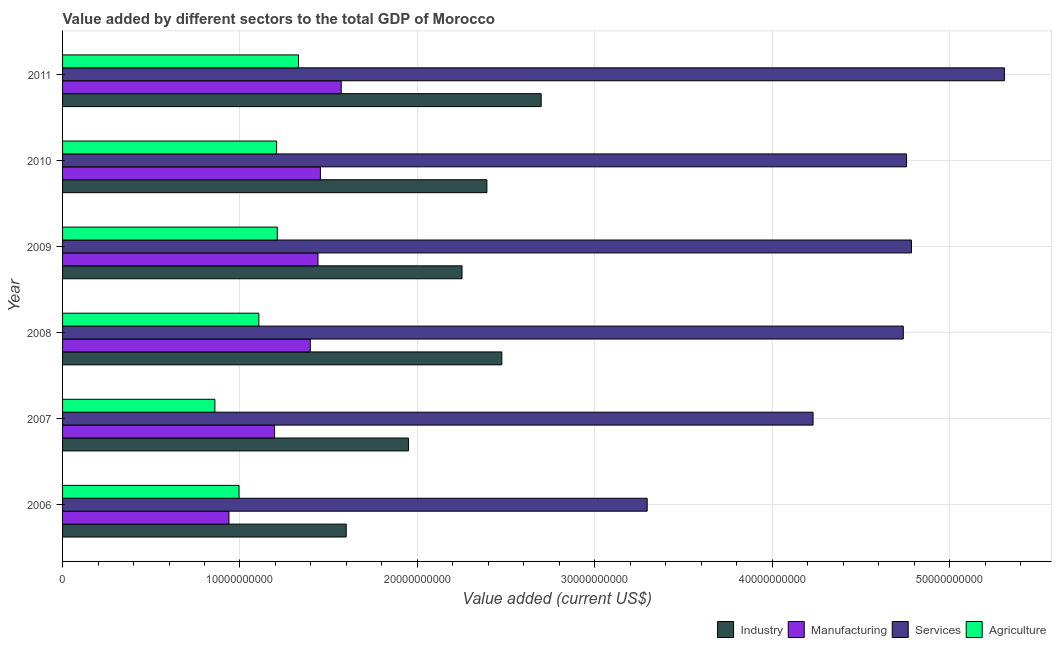Are the number of bars per tick equal to the number of legend labels?
Provide a short and direct response. Yes. Are the number of bars on each tick of the Y-axis equal?
Your answer should be compact. Yes. What is the label of the 1st group of bars from the top?
Your answer should be very brief. 2011. What is the value added by services sector in 2008?
Your answer should be very brief. 4.74e+1. Across all years, what is the maximum value added by manufacturing sector?
Your answer should be very brief. 1.57e+1. Across all years, what is the minimum value added by services sector?
Give a very brief answer. 3.30e+1. What is the total value added by agricultural sector in the graph?
Your answer should be compact. 6.71e+1. What is the difference between the value added by industrial sector in 2009 and that in 2011?
Your response must be concise. -4.46e+09. What is the difference between the value added by services sector in 2006 and the value added by industrial sector in 2008?
Make the answer very short. 8.19e+09. What is the average value added by agricultural sector per year?
Keep it short and to the point. 1.12e+1. In the year 2009, what is the difference between the value added by industrial sector and value added by agricultural sector?
Ensure brevity in your answer.  1.04e+1. In how many years, is the value added by agricultural sector greater than 22000000000 US$?
Your answer should be compact. 0. Is the difference between the value added by manufacturing sector in 2008 and 2009 greater than the difference between the value added by agricultural sector in 2008 and 2009?
Your answer should be very brief. Yes. What is the difference between the highest and the second highest value added by services sector?
Provide a short and direct response. 5.24e+09. What is the difference between the highest and the lowest value added by manufacturing sector?
Offer a terse response. 6.33e+09. Is the sum of the value added by services sector in 2007 and 2011 greater than the maximum value added by industrial sector across all years?
Provide a succinct answer. Yes. Is it the case that in every year, the sum of the value added by industrial sector and value added by services sector is greater than the sum of value added by manufacturing sector and value added by agricultural sector?
Provide a succinct answer. Yes. What does the 1st bar from the top in 2007 represents?
Keep it short and to the point. Agriculture. What does the 3rd bar from the bottom in 2006 represents?
Keep it short and to the point. Services. Is it the case that in every year, the sum of the value added by industrial sector and value added by manufacturing sector is greater than the value added by services sector?
Make the answer very short. No. What is the difference between two consecutive major ticks on the X-axis?
Offer a terse response. 1.00e+1. Does the graph contain any zero values?
Provide a short and direct response. No. Where does the legend appear in the graph?
Offer a terse response. Bottom right. How are the legend labels stacked?
Provide a succinct answer. Horizontal. What is the title of the graph?
Provide a short and direct response. Value added by different sectors to the total GDP of Morocco. What is the label or title of the X-axis?
Make the answer very short. Value added (current US$). What is the label or title of the Y-axis?
Offer a terse response. Year. What is the Value added (current US$) in Industry in 2006?
Make the answer very short. 1.60e+1. What is the Value added (current US$) in Manufacturing in 2006?
Ensure brevity in your answer.  9.38e+09. What is the Value added (current US$) in Services in 2006?
Provide a short and direct response. 3.30e+1. What is the Value added (current US$) of Agriculture in 2006?
Offer a terse response. 9.95e+09. What is the Value added (current US$) of Industry in 2007?
Your answer should be compact. 1.95e+1. What is the Value added (current US$) of Manufacturing in 2007?
Your answer should be very brief. 1.20e+1. What is the Value added (current US$) of Services in 2007?
Your response must be concise. 4.23e+1. What is the Value added (current US$) in Agriculture in 2007?
Make the answer very short. 8.59e+09. What is the Value added (current US$) in Industry in 2008?
Give a very brief answer. 2.48e+1. What is the Value added (current US$) of Manufacturing in 2008?
Provide a succinct answer. 1.40e+1. What is the Value added (current US$) in Services in 2008?
Provide a short and direct response. 4.74e+1. What is the Value added (current US$) of Agriculture in 2008?
Offer a very short reply. 1.11e+1. What is the Value added (current US$) in Industry in 2009?
Give a very brief answer. 2.25e+1. What is the Value added (current US$) in Manufacturing in 2009?
Ensure brevity in your answer.  1.44e+1. What is the Value added (current US$) of Services in 2009?
Provide a short and direct response. 4.78e+1. What is the Value added (current US$) in Agriculture in 2009?
Make the answer very short. 1.21e+1. What is the Value added (current US$) in Industry in 2010?
Offer a terse response. 2.39e+1. What is the Value added (current US$) of Manufacturing in 2010?
Make the answer very short. 1.45e+1. What is the Value added (current US$) in Services in 2010?
Your response must be concise. 4.76e+1. What is the Value added (current US$) in Agriculture in 2010?
Your answer should be very brief. 1.21e+1. What is the Value added (current US$) of Industry in 2011?
Your answer should be very brief. 2.70e+1. What is the Value added (current US$) in Manufacturing in 2011?
Provide a short and direct response. 1.57e+1. What is the Value added (current US$) in Services in 2011?
Offer a terse response. 5.31e+1. What is the Value added (current US$) of Agriculture in 2011?
Keep it short and to the point. 1.33e+1. Across all years, what is the maximum Value added (current US$) in Industry?
Offer a very short reply. 2.70e+1. Across all years, what is the maximum Value added (current US$) of Manufacturing?
Ensure brevity in your answer.  1.57e+1. Across all years, what is the maximum Value added (current US$) in Services?
Make the answer very short. 5.31e+1. Across all years, what is the maximum Value added (current US$) in Agriculture?
Ensure brevity in your answer.  1.33e+1. Across all years, what is the minimum Value added (current US$) in Industry?
Provide a succinct answer. 1.60e+1. Across all years, what is the minimum Value added (current US$) in Manufacturing?
Keep it short and to the point. 9.38e+09. Across all years, what is the minimum Value added (current US$) in Services?
Give a very brief answer. 3.30e+1. Across all years, what is the minimum Value added (current US$) of Agriculture?
Give a very brief answer. 8.59e+09. What is the total Value added (current US$) of Industry in the graph?
Make the answer very short. 1.34e+11. What is the total Value added (current US$) in Manufacturing in the graph?
Your response must be concise. 7.99e+1. What is the total Value added (current US$) in Services in the graph?
Make the answer very short. 2.71e+11. What is the total Value added (current US$) in Agriculture in the graph?
Ensure brevity in your answer.  6.71e+1. What is the difference between the Value added (current US$) of Industry in 2006 and that in 2007?
Your answer should be compact. -3.51e+09. What is the difference between the Value added (current US$) of Manufacturing in 2006 and that in 2007?
Provide a short and direct response. -2.57e+09. What is the difference between the Value added (current US$) of Services in 2006 and that in 2007?
Provide a short and direct response. -9.35e+09. What is the difference between the Value added (current US$) of Agriculture in 2006 and that in 2007?
Your response must be concise. 1.36e+09. What is the difference between the Value added (current US$) of Industry in 2006 and that in 2008?
Provide a succinct answer. -8.77e+09. What is the difference between the Value added (current US$) in Manufacturing in 2006 and that in 2008?
Give a very brief answer. -4.58e+09. What is the difference between the Value added (current US$) of Services in 2006 and that in 2008?
Provide a short and direct response. -1.44e+1. What is the difference between the Value added (current US$) of Agriculture in 2006 and that in 2008?
Ensure brevity in your answer.  -1.12e+09. What is the difference between the Value added (current US$) of Industry in 2006 and that in 2009?
Offer a very short reply. -6.53e+09. What is the difference between the Value added (current US$) of Manufacturing in 2006 and that in 2009?
Provide a succinct answer. -5.02e+09. What is the difference between the Value added (current US$) of Services in 2006 and that in 2009?
Provide a short and direct response. -1.49e+1. What is the difference between the Value added (current US$) in Agriculture in 2006 and that in 2009?
Your response must be concise. -2.16e+09. What is the difference between the Value added (current US$) in Industry in 2006 and that in 2010?
Give a very brief answer. -7.93e+09. What is the difference between the Value added (current US$) of Manufacturing in 2006 and that in 2010?
Keep it short and to the point. -5.15e+09. What is the difference between the Value added (current US$) in Services in 2006 and that in 2010?
Ensure brevity in your answer.  -1.46e+1. What is the difference between the Value added (current US$) in Agriculture in 2006 and that in 2010?
Offer a very short reply. -2.12e+09. What is the difference between the Value added (current US$) of Industry in 2006 and that in 2011?
Your answer should be compact. -1.10e+1. What is the difference between the Value added (current US$) in Manufacturing in 2006 and that in 2011?
Your response must be concise. -6.33e+09. What is the difference between the Value added (current US$) in Services in 2006 and that in 2011?
Make the answer very short. -2.01e+1. What is the difference between the Value added (current US$) of Agriculture in 2006 and that in 2011?
Offer a terse response. -3.35e+09. What is the difference between the Value added (current US$) of Industry in 2007 and that in 2008?
Your answer should be compact. -5.26e+09. What is the difference between the Value added (current US$) in Manufacturing in 2007 and that in 2008?
Offer a very short reply. -2.01e+09. What is the difference between the Value added (current US$) in Services in 2007 and that in 2008?
Offer a terse response. -5.09e+09. What is the difference between the Value added (current US$) in Agriculture in 2007 and that in 2008?
Ensure brevity in your answer.  -2.48e+09. What is the difference between the Value added (current US$) in Industry in 2007 and that in 2009?
Provide a succinct answer. -3.02e+09. What is the difference between the Value added (current US$) of Manufacturing in 2007 and that in 2009?
Provide a succinct answer. -2.45e+09. What is the difference between the Value added (current US$) of Services in 2007 and that in 2009?
Provide a succinct answer. -5.55e+09. What is the difference between the Value added (current US$) of Agriculture in 2007 and that in 2009?
Keep it short and to the point. -3.52e+09. What is the difference between the Value added (current US$) of Industry in 2007 and that in 2010?
Your answer should be very brief. -4.42e+09. What is the difference between the Value added (current US$) of Manufacturing in 2007 and that in 2010?
Keep it short and to the point. -2.58e+09. What is the difference between the Value added (current US$) of Services in 2007 and that in 2010?
Ensure brevity in your answer.  -5.27e+09. What is the difference between the Value added (current US$) of Agriculture in 2007 and that in 2010?
Keep it short and to the point. -3.48e+09. What is the difference between the Value added (current US$) in Industry in 2007 and that in 2011?
Your answer should be compact. -7.48e+09. What is the difference between the Value added (current US$) in Manufacturing in 2007 and that in 2011?
Make the answer very short. -3.76e+09. What is the difference between the Value added (current US$) in Services in 2007 and that in 2011?
Ensure brevity in your answer.  -1.08e+1. What is the difference between the Value added (current US$) in Agriculture in 2007 and that in 2011?
Offer a terse response. -4.71e+09. What is the difference between the Value added (current US$) of Industry in 2008 and that in 2009?
Ensure brevity in your answer.  2.24e+09. What is the difference between the Value added (current US$) in Manufacturing in 2008 and that in 2009?
Your response must be concise. -4.36e+08. What is the difference between the Value added (current US$) of Services in 2008 and that in 2009?
Make the answer very short. -4.59e+08. What is the difference between the Value added (current US$) of Agriculture in 2008 and that in 2009?
Offer a very short reply. -1.04e+09. What is the difference between the Value added (current US$) in Industry in 2008 and that in 2010?
Provide a short and direct response. 8.42e+08. What is the difference between the Value added (current US$) of Manufacturing in 2008 and that in 2010?
Provide a short and direct response. -5.71e+08. What is the difference between the Value added (current US$) in Services in 2008 and that in 2010?
Offer a terse response. -1.85e+08. What is the difference between the Value added (current US$) in Agriculture in 2008 and that in 2010?
Give a very brief answer. -1.00e+09. What is the difference between the Value added (current US$) of Industry in 2008 and that in 2011?
Your answer should be compact. -2.22e+09. What is the difference between the Value added (current US$) in Manufacturing in 2008 and that in 2011?
Offer a very short reply. -1.74e+09. What is the difference between the Value added (current US$) of Services in 2008 and that in 2011?
Your answer should be very brief. -5.70e+09. What is the difference between the Value added (current US$) in Agriculture in 2008 and that in 2011?
Keep it short and to the point. -2.24e+09. What is the difference between the Value added (current US$) in Industry in 2009 and that in 2010?
Your answer should be compact. -1.40e+09. What is the difference between the Value added (current US$) of Manufacturing in 2009 and that in 2010?
Give a very brief answer. -1.35e+08. What is the difference between the Value added (current US$) of Services in 2009 and that in 2010?
Keep it short and to the point. 2.74e+08. What is the difference between the Value added (current US$) of Agriculture in 2009 and that in 2010?
Your answer should be very brief. 3.77e+07. What is the difference between the Value added (current US$) in Industry in 2009 and that in 2011?
Offer a very short reply. -4.46e+09. What is the difference between the Value added (current US$) in Manufacturing in 2009 and that in 2011?
Your answer should be compact. -1.31e+09. What is the difference between the Value added (current US$) of Services in 2009 and that in 2011?
Keep it short and to the point. -5.24e+09. What is the difference between the Value added (current US$) of Agriculture in 2009 and that in 2011?
Your answer should be compact. -1.20e+09. What is the difference between the Value added (current US$) of Industry in 2010 and that in 2011?
Your answer should be compact. -3.06e+09. What is the difference between the Value added (current US$) of Manufacturing in 2010 and that in 2011?
Provide a succinct answer. -1.17e+09. What is the difference between the Value added (current US$) in Services in 2010 and that in 2011?
Offer a terse response. -5.51e+09. What is the difference between the Value added (current US$) of Agriculture in 2010 and that in 2011?
Make the answer very short. -1.23e+09. What is the difference between the Value added (current US$) of Industry in 2006 and the Value added (current US$) of Manufacturing in 2007?
Offer a terse response. 4.04e+09. What is the difference between the Value added (current US$) in Industry in 2006 and the Value added (current US$) in Services in 2007?
Offer a very short reply. -2.63e+1. What is the difference between the Value added (current US$) of Industry in 2006 and the Value added (current US$) of Agriculture in 2007?
Give a very brief answer. 7.40e+09. What is the difference between the Value added (current US$) in Manufacturing in 2006 and the Value added (current US$) in Services in 2007?
Offer a terse response. -3.29e+1. What is the difference between the Value added (current US$) of Manufacturing in 2006 and the Value added (current US$) of Agriculture in 2007?
Ensure brevity in your answer.  7.93e+08. What is the difference between the Value added (current US$) in Services in 2006 and the Value added (current US$) in Agriculture in 2007?
Provide a short and direct response. 2.44e+1. What is the difference between the Value added (current US$) of Industry in 2006 and the Value added (current US$) of Manufacturing in 2008?
Your answer should be very brief. 2.03e+09. What is the difference between the Value added (current US$) in Industry in 2006 and the Value added (current US$) in Services in 2008?
Make the answer very short. -3.14e+1. What is the difference between the Value added (current US$) of Industry in 2006 and the Value added (current US$) of Agriculture in 2008?
Offer a very short reply. 4.93e+09. What is the difference between the Value added (current US$) of Manufacturing in 2006 and the Value added (current US$) of Services in 2008?
Make the answer very short. -3.80e+1. What is the difference between the Value added (current US$) in Manufacturing in 2006 and the Value added (current US$) in Agriculture in 2008?
Make the answer very short. -1.68e+09. What is the difference between the Value added (current US$) in Services in 2006 and the Value added (current US$) in Agriculture in 2008?
Provide a succinct answer. 2.19e+1. What is the difference between the Value added (current US$) of Industry in 2006 and the Value added (current US$) of Manufacturing in 2009?
Provide a short and direct response. 1.59e+09. What is the difference between the Value added (current US$) in Industry in 2006 and the Value added (current US$) in Services in 2009?
Your answer should be compact. -3.19e+1. What is the difference between the Value added (current US$) in Industry in 2006 and the Value added (current US$) in Agriculture in 2009?
Give a very brief answer. 3.89e+09. What is the difference between the Value added (current US$) of Manufacturing in 2006 and the Value added (current US$) of Services in 2009?
Make the answer very short. -3.85e+1. What is the difference between the Value added (current US$) of Manufacturing in 2006 and the Value added (current US$) of Agriculture in 2009?
Ensure brevity in your answer.  -2.72e+09. What is the difference between the Value added (current US$) of Services in 2006 and the Value added (current US$) of Agriculture in 2009?
Your answer should be compact. 2.08e+1. What is the difference between the Value added (current US$) in Industry in 2006 and the Value added (current US$) in Manufacturing in 2010?
Provide a short and direct response. 1.46e+09. What is the difference between the Value added (current US$) in Industry in 2006 and the Value added (current US$) in Services in 2010?
Your answer should be compact. -3.16e+1. What is the difference between the Value added (current US$) in Industry in 2006 and the Value added (current US$) in Agriculture in 2010?
Make the answer very short. 3.92e+09. What is the difference between the Value added (current US$) of Manufacturing in 2006 and the Value added (current US$) of Services in 2010?
Make the answer very short. -3.82e+1. What is the difference between the Value added (current US$) of Manufacturing in 2006 and the Value added (current US$) of Agriculture in 2010?
Make the answer very short. -2.69e+09. What is the difference between the Value added (current US$) in Services in 2006 and the Value added (current US$) in Agriculture in 2010?
Your response must be concise. 2.09e+1. What is the difference between the Value added (current US$) of Industry in 2006 and the Value added (current US$) of Manufacturing in 2011?
Offer a very short reply. 2.83e+08. What is the difference between the Value added (current US$) of Industry in 2006 and the Value added (current US$) of Services in 2011?
Make the answer very short. -3.71e+1. What is the difference between the Value added (current US$) in Industry in 2006 and the Value added (current US$) in Agriculture in 2011?
Keep it short and to the point. 2.69e+09. What is the difference between the Value added (current US$) of Manufacturing in 2006 and the Value added (current US$) of Services in 2011?
Make the answer very short. -4.37e+1. What is the difference between the Value added (current US$) of Manufacturing in 2006 and the Value added (current US$) of Agriculture in 2011?
Keep it short and to the point. -3.92e+09. What is the difference between the Value added (current US$) of Services in 2006 and the Value added (current US$) of Agriculture in 2011?
Provide a short and direct response. 1.97e+1. What is the difference between the Value added (current US$) of Industry in 2007 and the Value added (current US$) of Manufacturing in 2008?
Offer a very short reply. 5.53e+09. What is the difference between the Value added (current US$) in Industry in 2007 and the Value added (current US$) in Services in 2008?
Your answer should be compact. -2.79e+1. What is the difference between the Value added (current US$) in Industry in 2007 and the Value added (current US$) in Agriculture in 2008?
Offer a very short reply. 8.43e+09. What is the difference between the Value added (current US$) in Manufacturing in 2007 and the Value added (current US$) in Services in 2008?
Keep it short and to the point. -3.54e+1. What is the difference between the Value added (current US$) in Manufacturing in 2007 and the Value added (current US$) in Agriculture in 2008?
Your answer should be compact. 8.87e+08. What is the difference between the Value added (current US$) of Services in 2007 and the Value added (current US$) of Agriculture in 2008?
Provide a short and direct response. 3.12e+1. What is the difference between the Value added (current US$) of Industry in 2007 and the Value added (current US$) of Manufacturing in 2009?
Your response must be concise. 5.10e+09. What is the difference between the Value added (current US$) of Industry in 2007 and the Value added (current US$) of Services in 2009?
Ensure brevity in your answer.  -2.84e+1. What is the difference between the Value added (current US$) of Industry in 2007 and the Value added (current US$) of Agriculture in 2009?
Your answer should be very brief. 7.39e+09. What is the difference between the Value added (current US$) in Manufacturing in 2007 and the Value added (current US$) in Services in 2009?
Ensure brevity in your answer.  -3.59e+1. What is the difference between the Value added (current US$) in Manufacturing in 2007 and the Value added (current US$) in Agriculture in 2009?
Provide a succinct answer. -1.53e+08. What is the difference between the Value added (current US$) of Services in 2007 and the Value added (current US$) of Agriculture in 2009?
Give a very brief answer. 3.02e+1. What is the difference between the Value added (current US$) in Industry in 2007 and the Value added (current US$) in Manufacturing in 2010?
Your answer should be compact. 4.96e+09. What is the difference between the Value added (current US$) in Industry in 2007 and the Value added (current US$) in Services in 2010?
Your response must be concise. -2.81e+1. What is the difference between the Value added (current US$) in Industry in 2007 and the Value added (current US$) in Agriculture in 2010?
Offer a terse response. 7.43e+09. What is the difference between the Value added (current US$) in Manufacturing in 2007 and the Value added (current US$) in Services in 2010?
Offer a terse response. -3.56e+1. What is the difference between the Value added (current US$) of Manufacturing in 2007 and the Value added (current US$) of Agriculture in 2010?
Offer a very short reply. -1.16e+08. What is the difference between the Value added (current US$) in Services in 2007 and the Value added (current US$) in Agriculture in 2010?
Your answer should be compact. 3.02e+1. What is the difference between the Value added (current US$) of Industry in 2007 and the Value added (current US$) of Manufacturing in 2011?
Provide a short and direct response. 3.79e+09. What is the difference between the Value added (current US$) of Industry in 2007 and the Value added (current US$) of Services in 2011?
Make the answer very short. -3.36e+1. What is the difference between the Value added (current US$) in Industry in 2007 and the Value added (current US$) in Agriculture in 2011?
Make the answer very short. 6.20e+09. What is the difference between the Value added (current US$) of Manufacturing in 2007 and the Value added (current US$) of Services in 2011?
Your response must be concise. -4.11e+1. What is the difference between the Value added (current US$) in Manufacturing in 2007 and the Value added (current US$) in Agriculture in 2011?
Provide a short and direct response. -1.35e+09. What is the difference between the Value added (current US$) in Services in 2007 and the Value added (current US$) in Agriculture in 2011?
Provide a short and direct response. 2.90e+1. What is the difference between the Value added (current US$) of Industry in 2008 and the Value added (current US$) of Manufacturing in 2009?
Provide a short and direct response. 1.04e+1. What is the difference between the Value added (current US$) of Industry in 2008 and the Value added (current US$) of Services in 2009?
Your response must be concise. -2.31e+1. What is the difference between the Value added (current US$) of Industry in 2008 and the Value added (current US$) of Agriculture in 2009?
Provide a succinct answer. 1.27e+1. What is the difference between the Value added (current US$) of Manufacturing in 2008 and the Value added (current US$) of Services in 2009?
Provide a short and direct response. -3.39e+1. What is the difference between the Value added (current US$) in Manufacturing in 2008 and the Value added (current US$) in Agriculture in 2009?
Keep it short and to the point. 1.86e+09. What is the difference between the Value added (current US$) in Services in 2008 and the Value added (current US$) in Agriculture in 2009?
Make the answer very short. 3.53e+1. What is the difference between the Value added (current US$) of Industry in 2008 and the Value added (current US$) of Manufacturing in 2010?
Provide a short and direct response. 1.02e+1. What is the difference between the Value added (current US$) in Industry in 2008 and the Value added (current US$) in Services in 2010?
Keep it short and to the point. -2.28e+1. What is the difference between the Value added (current US$) in Industry in 2008 and the Value added (current US$) in Agriculture in 2010?
Your response must be concise. 1.27e+1. What is the difference between the Value added (current US$) in Manufacturing in 2008 and the Value added (current US$) in Services in 2010?
Keep it short and to the point. -3.36e+1. What is the difference between the Value added (current US$) of Manufacturing in 2008 and the Value added (current US$) of Agriculture in 2010?
Provide a short and direct response. 1.90e+09. What is the difference between the Value added (current US$) of Services in 2008 and the Value added (current US$) of Agriculture in 2010?
Your answer should be very brief. 3.53e+1. What is the difference between the Value added (current US$) in Industry in 2008 and the Value added (current US$) in Manufacturing in 2011?
Your response must be concise. 9.05e+09. What is the difference between the Value added (current US$) of Industry in 2008 and the Value added (current US$) of Services in 2011?
Keep it short and to the point. -2.83e+1. What is the difference between the Value added (current US$) in Industry in 2008 and the Value added (current US$) in Agriculture in 2011?
Your answer should be very brief. 1.15e+1. What is the difference between the Value added (current US$) of Manufacturing in 2008 and the Value added (current US$) of Services in 2011?
Your answer should be compact. -3.91e+1. What is the difference between the Value added (current US$) of Manufacturing in 2008 and the Value added (current US$) of Agriculture in 2011?
Ensure brevity in your answer.  6.62e+08. What is the difference between the Value added (current US$) of Services in 2008 and the Value added (current US$) of Agriculture in 2011?
Give a very brief answer. 3.41e+1. What is the difference between the Value added (current US$) of Industry in 2009 and the Value added (current US$) of Manufacturing in 2010?
Offer a terse response. 7.98e+09. What is the difference between the Value added (current US$) of Industry in 2009 and the Value added (current US$) of Services in 2010?
Your answer should be compact. -2.51e+1. What is the difference between the Value added (current US$) in Industry in 2009 and the Value added (current US$) in Agriculture in 2010?
Offer a very short reply. 1.05e+1. What is the difference between the Value added (current US$) in Manufacturing in 2009 and the Value added (current US$) in Services in 2010?
Your answer should be compact. -3.32e+1. What is the difference between the Value added (current US$) of Manufacturing in 2009 and the Value added (current US$) of Agriculture in 2010?
Offer a terse response. 2.33e+09. What is the difference between the Value added (current US$) of Services in 2009 and the Value added (current US$) of Agriculture in 2010?
Give a very brief answer. 3.58e+1. What is the difference between the Value added (current US$) of Industry in 2009 and the Value added (current US$) of Manufacturing in 2011?
Give a very brief answer. 6.81e+09. What is the difference between the Value added (current US$) in Industry in 2009 and the Value added (current US$) in Services in 2011?
Your answer should be very brief. -3.06e+1. What is the difference between the Value added (current US$) of Industry in 2009 and the Value added (current US$) of Agriculture in 2011?
Provide a succinct answer. 9.22e+09. What is the difference between the Value added (current US$) in Manufacturing in 2009 and the Value added (current US$) in Services in 2011?
Provide a short and direct response. -3.87e+1. What is the difference between the Value added (current US$) in Manufacturing in 2009 and the Value added (current US$) in Agriculture in 2011?
Make the answer very short. 1.10e+09. What is the difference between the Value added (current US$) of Services in 2009 and the Value added (current US$) of Agriculture in 2011?
Your answer should be very brief. 3.45e+1. What is the difference between the Value added (current US$) in Industry in 2010 and the Value added (current US$) in Manufacturing in 2011?
Ensure brevity in your answer.  8.21e+09. What is the difference between the Value added (current US$) in Industry in 2010 and the Value added (current US$) in Services in 2011?
Your answer should be compact. -2.92e+1. What is the difference between the Value added (current US$) in Industry in 2010 and the Value added (current US$) in Agriculture in 2011?
Your answer should be compact. 1.06e+1. What is the difference between the Value added (current US$) in Manufacturing in 2010 and the Value added (current US$) in Services in 2011?
Keep it short and to the point. -3.86e+1. What is the difference between the Value added (current US$) in Manufacturing in 2010 and the Value added (current US$) in Agriculture in 2011?
Your response must be concise. 1.23e+09. What is the difference between the Value added (current US$) of Services in 2010 and the Value added (current US$) of Agriculture in 2011?
Keep it short and to the point. 3.43e+1. What is the average Value added (current US$) in Industry per year?
Give a very brief answer. 2.23e+1. What is the average Value added (current US$) in Manufacturing per year?
Give a very brief answer. 1.33e+1. What is the average Value added (current US$) of Services per year?
Provide a short and direct response. 4.52e+1. What is the average Value added (current US$) of Agriculture per year?
Provide a short and direct response. 1.12e+1. In the year 2006, what is the difference between the Value added (current US$) of Industry and Value added (current US$) of Manufacturing?
Ensure brevity in your answer.  6.61e+09. In the year 2006, what is the difference between the Value added (current US$) in Industry and Value added (current US$) in Services?
Provide a succinct answer. -1.70e+1. In the year 2006, what is the difference between the Value added (current US$) in Industry and Value added (current US$) in Agriculture?
Offer a terse response. 6.04e+09. In the year 2006, what is the difference between the Value added (current US$) of Manufacturing and Value added (current US$) of Services?
Provide a succinct answer. -2.36e+1. In the year 2006, what is the difference between the Value added (current US$) of Manufacturing and Value added (current US$) of Agriculture?
Your answer should be compact. -5.67e+08. In the year 2006, what is the difference between the Value added (current US$) of Services and Value added (current US$) of Agriculture?
Ensure brevity in your answer.  2.30e+1. In the year 2007, what is the difference between the Value added (current US$) of Industry and Value added (current US$) of Manufacturing?
Provide a succinct answer. 7.55e+09. In the year 2007, what is the difference between the Value added (current US$) of Industry and Value added (current US$) of Services?
Your answer should be compact. -2.28e+1. In the year 2007, what is the difference between the Value added (current US$) of Industry and Value added (current US$) of Agriculture?
Your answer should be compact. 1.09e+1. In the year 2007, what is the difference between the Value added (current US$) of Manufacturing and Value added (current US$) of Services?
Give a very brief answer. -3.04e+1. In the year 2007, what is the difference between the Value added (current US$) in Manufacturing and Value added (current US$) in Agriculture?
Give a very brief answer. 3.36e+09. In the year 2007, what is the difference between the Value added (current US$) in Services and Value added (current US$) in Agriculture?
Ensure brevity in your answer.  3.37e+1. In the year 2008, what is the difference between the Value added (current US$) of Industry and Value added (current US$) of Manufacturing?
Offer a very short reply. 1.08e+1. In the year 2008, what is the difference between the Value added (current US$) of Industry and Value added (current US$) of Services?
Your answer should be very brief. -2.26e+1. In the year 2008, what is the difference between the Value added (current US$) in Industry and Value added (current US$) in Agriculture?
Your response must be concise. 1.37e+1. In the year 2008, what is the difference between the Value added (current US$) in Manufacturing and Value added (current US$) in Services?
Make the answer very short. -3.34e+1. In the year 2008, what is the difference between the Value added (current US$) of Manufacturing and Value added (current US$) of Agriculture?
Your response must be concise. 2.90e+09. In the year 2008, what is the difference between the Value added (current US$) in Services and Value added (current US$) in Agriculture?
Ensure brevity in your answer.  3.63e+1. In the year 2009, what is the difference between the Value added (current US$) in Industry and Value added (current US$) in Manufacturing?
Offer a very short reply. 8.12e+09. In the year 2009, what is the difference between the Value added (current US$) in Industry and Value added (current US$) in Services?
Keep it short and to the point. -2.53e+1. In the year 2009, what is the difference between the Value added (current US$) in Industry and Value added (current US$) in Agriculture?
Your answer should be very brief. 1.04e+1. In the year 2009, what is the difference between the Value added (current US$) of Manufacturing and Value added (current US$) of Services?
Give a very brief answer. -3.34e+1. In the year 2009, what is the difference between the Value added (current US$) in Manufacturing and Value added (current US$) in Agriculture?
Your response must be concise. 2.29e+09. In the year 2009, what is the difference between the Value added (current US$) in Services and Value added (current US$) in Agriculture?
Make the answer very short. 3.57e+1. In the year 2010, what is the difference between the Value added (current US$) in Industry and Value added (current US$) in Manufacturing?
Your response must be concise. 9.38e+09. In the year 2010, what is the difference between the Value added (current US$) of Industry and Value added (current US$) of Services?
Your response must be concise. -2.37e+1. In the year 2010, what is the difference between the Value added (current US$) in Industry and Value added (current US$) in Agriculture?
Give a very brief answer. 1.19e+1. In the year 2010, what is the difference between the Value added (current US$) in Manufacturing and Value added (current US$) in Services?
Your answer should be very brief. -3.30e+1. In the year 2010, what is the difference between the Value added (current US$) of Manufacturing and Value added (current US$) of Agriculture?
Ensure brevity in your answer.  2.47e+09. In the year 2010, what is the difference between the Value added (current US$) in Services and Value added (current US$) in Agriculture?
Offer a terse response. 3.55e+1. In the year 2011, what is the difference between the Value added (current US$) of Industry and Value added (current US$) of Manufacturing?
Offer a very short reply. 1.13e+1. In the year 2011, what is the difference between the Value added (current US$) of Industry and Value added (current US$) of Services?
Make the answer very short. -2.61e+1. In the year 2011, what is the difference between the Value added (current US$) of Industry and Value added (current US$) of Agriculture?
Offer a very short reply. 1.37e+1. In the year 2011, what is the difference between the Value added (current US$) of Manufacturing and Value added (current US$) of Services?
Offer a very short reply. -3.74e+1. In the year 2011, what is the difference between the Value added (current US$) of Manufacturing and Value added (current US$) of Agriculture?
Provide a succinct answer. 2.41e+09. In the year 2011, what is the difference between the Value added (current US$) in Services and Value added (current US$) in Agriculture?
Your response must be concise. 3.98e+1. What is the ratio of the Value added (current US$) of Industry in 2006 to that in 2007?
Your answer should be compact. 0.82. What is the ratio of the Value added (current US$) of Manufacturing in 2006 to that in 2007?
Make the answer very short. 0.78. What is the ratio of the Value added (current US$) of Services in 2006 to that in 2007?
Your answer should be very brief. 0.78. What is the ratio of the Value added (current US$) of Agriculture in 2006 to that in 2007?
Make the answer very short. 1.16. What is the ratio of the Value added (current US$) of Industry in 2006 to that in 2008?
Offer a terse response. 0.65. What is the ratio of the Value added (current US$) in Manufacturing in 2006 to that in 2008?
Your response must be concise. 0.67. What is the ratio of the Value added (current US$) in Services in 2006 to that in 2008?
Make the answer very short. 0.7. What is the ratio of the Value added (current US$) of Agriculture in 2006 to that in 2008?
Ensure brevity in your answer.  0.9. What is the ratio of the Value added (current US$) of Industry in 2006 to that in 2009?
Offer a terse response. 0.71. What is the ratio of the Value added (current US$) of Manufacturing in 2006 to that in 2009?
Offer a terse response. 0.65. What is the ratio of the Value added (current US$) in Services in 2006 to that in 2009?
Offer a very short reply. 0.69. What is the ratio of the Value added (current US$) of Agriculture in 2006 to that in 2009?
Your answer should be compact. 0.82. What is the ratio of the Value added (current US$) of Industry in 2006 to that in 2010?
Offer a terse response. 0.67. What is the ratio of the Value added (current US$) of Manufacturing in 2006 to that in 2010?
Your answer should be compact. 0.65. What is the ratio of the Value added (current US$) in Services in 2006 to that in 2010?
Provide a succinct answer. 0.69. What is the ratio of the Value added (current US$) in Agriculture in 2006 to that in 2010?
Provide a short and direct response. 0.82. What is the ratio of the Value added (current US$) of Industry in 2006 to that in 2011?
Your answer should be very brief. 0.59. What is the ratio of the Value added (current US$) of Manufacturing in 2006 to that in 2011?
Your answer should be compact. 0.6. What is the ratio of the Value added (current US$) of Services in 2006 to that in 2011?
Ensure brevity in your answer.  0.62. What is the ratio of the Value added (current US$) in Agriculture in 2006 to that in 2011?
Offer a terse response. 0.75. What is the ratio of the Value added (current US$) of Industry in 2007 to that in 2008?
Your response must be concise. 0.79. What is the ratio of the Value added (current US$) of Manufacturing in 2007 to that in 2008?
Your answer should be compact. 0.86. What is the ratio of the Value added (current US$) of Services in 2007 to that in 2008?
Give a very brief answer. 0.89. What is the ratio of the Value added (current US$) in Agriculture in 2007 to that in 2008?
Offer a very short reply. 0.78. What is the ratio of the Value added (current US$) of Industry in 2007 to that in 2009?
Offer a very short reply. 0.87. What is the ratio of the Value added (current US$) in Manufacturing in 2007 to that in 2009?
Make the answer very short. 0.83. What is the ratio of the Value added (current US$) in Services in 2007 to that in 2009?
Offer a terse response. 0.88. What is the ratio of the Value added (current US$) of Agriculture in 2007 to that in 2009?
Offer a terse response. 0.71. What is the ratio of the Value added (current US$) of Industry in 2007 to that in 2010?
Make the answer very short. 0.82. What is the ratio of the Value added (current US$) in Manufacturing in 2007 to that in 2010?
Keep it short and to the point. 0.82. What is the ratio of the Value added (current US$) in Services in 2007 to that in 2010?
Give a very brief answer. 0.89. What is the ratio of the Value added (current US$) of Agriculture in 2007 to that in 2010?
Keep it short and to the point. 0.71. What is the ratio of the Value added (current US$) of Industry in 2007 to that in 2011?
Ensure brevity in your answer.  0.72. What is the ratio of the Value added (current US$) of Manufacturing in 2007 to that in 2011?
Offer a terse response. 0.76. What is the ratio of the Value added (current US$) in Services in 2007 to that in 2011?
Make the answer very short. 0.8. What is the ratio of the Value added (current US$) in Agriculture in 2007 to that in 2011?
Offer a very short reply. 0.65. What is the ratio of the Value added (current US$) of Industry in 2008 to that in 2009?
Offer a very short reply. 1.1. What is the ratio of the Value added (current US$) in Manufacturing in 2008 to that in 2009?
Ensure brevity in your answer.  0.97. What is the ratio of the Value added (current US$) of Agriculture in 2008 to that in 2009?
Offer a terse response. 0.91. What is the ratio of the Value added (current US$) of Industry in 2008 to that in 2010?
Your answer should be compact. 1.04. What is the ratio of the Value added (current US$) in Manufacturing in 2008 to that in 2010?
Make the answer very short. 0.96. What is the ratio of the Value added (current US$) in Agriculture in 2008 to that in 2010?
Your response must be concise. 0.92. What is the ratio of the Value added (current US$) in Industry in 2008 to that in 2011?
Offer a very short reply. 0.92. What is the ratio of the Value added (current US$) of Manufacturing in 2008 to that in 2011?
Keep it short and to the point. 0.89. What is the ratio of the Value added (current US$) of Services in 2008 to that in 2011?
Offer a terse response. 0.89. What is the ratio of the Value added (current US$) of Agriculture in 2008 to that in 2011?
Give a very brief answer. 0.83. What is the ratio of the Value added (current US$) in Industry in 2009 to that in 2010?
Provide a succinct answer. 0.94. What is the ratio of the Value added (current US$) in Industry in 2009 to that in 2011?
Your answer should be compact. 0.83. What is the ratio of the Value added (current US$) in Services in 2009 to that in 2011?
Make the answer very short. 0.9. What is the ratio of the Value added (current US$) in Agriculture in 2009 to that in 2011?
Keep it short and to the point. 0.91. What is the ratio of the Value added (current US$) of Industry in 2010 to that in 2011?
Your answer should be compact. 0.89. What is the ratio of the Value added (current US$) in Manufacturing in 2010 to that in 2011?
Your answer should be compact. 0.93. What is the ratio of the Value added (current US$) in Services in 2010 to that in 2011?
Your answer should be very brief. 0.9. What is the ratio of the Value added (current US$) in Agriculture in 2010 to that in 2011?
Your response must be concise. 0.91. What is the difference between the highest and the second highest Value added (current US$) of Industry?
Offer a very short reply. 2.22e+09. What is the difference between the highest and the second highest Value added (current US$) of Manufacturing?
Make the answer very short. 1.17e+09. What is the difference between the highest and the second highest Value added (current US$) of Services?
Make the answer very short. 5.24e+09. What is the difference between the highest and the second highest Value added (current US$) in Agriculture?
Provide a short and direct response. 1.20e+09. What is the difference between the highest and the lowest Value added (current US$) of Industry?
Your answer should be very brief. 1.10e+1. What is the difference between the highest and the lowest Value added (current US$) of Manufacturing?
Offer a very short reply. 6.33e+09. What is the difference between the highest and the lowest Value added (current US$) in Services?
Make the answer very short. 2.01e+1. What is the difference between the highest and the lowest Value added (current US$) of Agriculture?
Provide a short and direct response. 4.71e+09. 